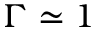<formula> <loc_0><loc_0><loc_500><loc_500>\Gamma \simeq 1</formula> 